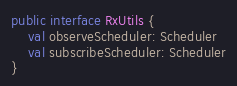Convert code to text. <code><loc_0><loc_0><loc_500><loc_500><_Kotlin_>public interface RxUtils {
    val observeScheduler: Scheduler
    val subscribeScheduler: Scheduler
}</code> 